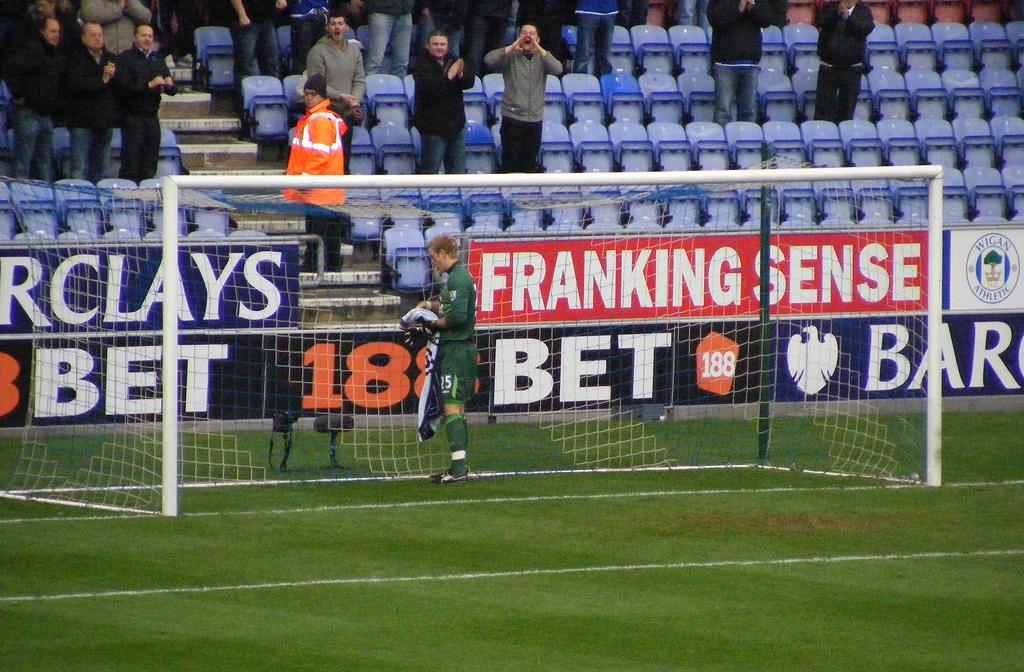Provide a one-sentence caption for the provided image. Franking Sense is a sponsor for this soccer field. 